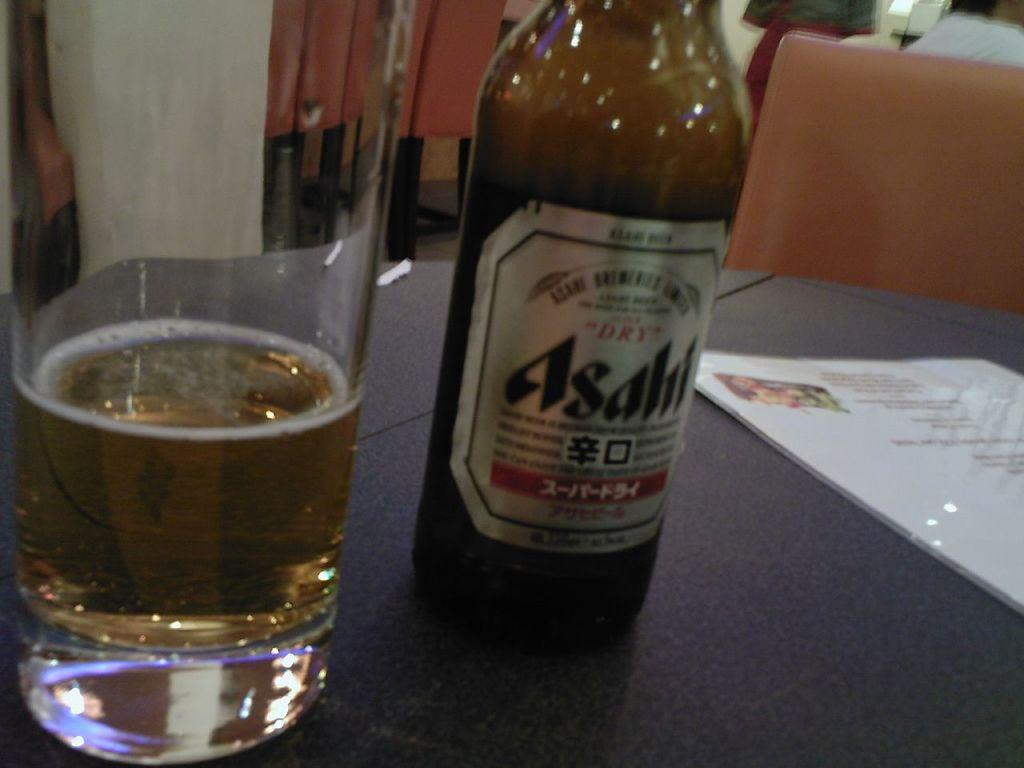<image>
Create a compact narrative representing the image presented. A bottle of Asahi is next to a nearly empty glass. 